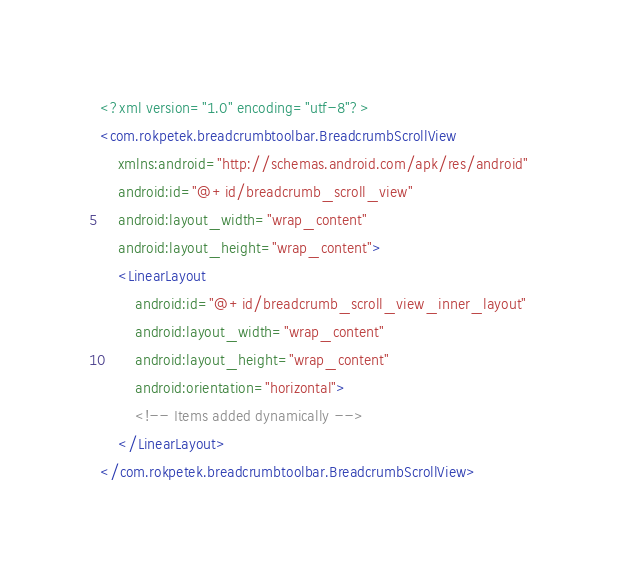Convert code to text. <code><loc_0><loc_0><loc_500><loc_500><_XML_><?xml version="1.0" encoding="utf-8"?>
<com.rokpetek.breadcrumbtoolbar.BreadcrumbScrollView
    xmlns:android="http://schemas.android.com/apk/res/android"
    android:id="@+id/breadcrumb_scroll_view"
    android:layout_width="wrap_content"
    android:layout_height="wrap_content">
    <LinearLayout
        android:id="@+id/breadcrumb_scroll_view_inner_layout"
        android:layout_width="wrap_content"
        android:layout_height="wrap_content"
        android:orientation="horizontal">
        <!-- Items added dynamically -->
    </LinearLayout>
</com.rokpetek.breadcrumbtoolbar.BreadcrumbScrollView></code> 